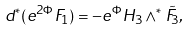<formula> <loc_0><loc_0><loc_500><loc_500>d ^ { * } ( e ^ { 2 \Phi } F _ { 1 } ) = - e ^ { \Phi } { H } _ { 3 } \wedge ^ { * } \tilde { F } _ { 3 } ,</formula> 